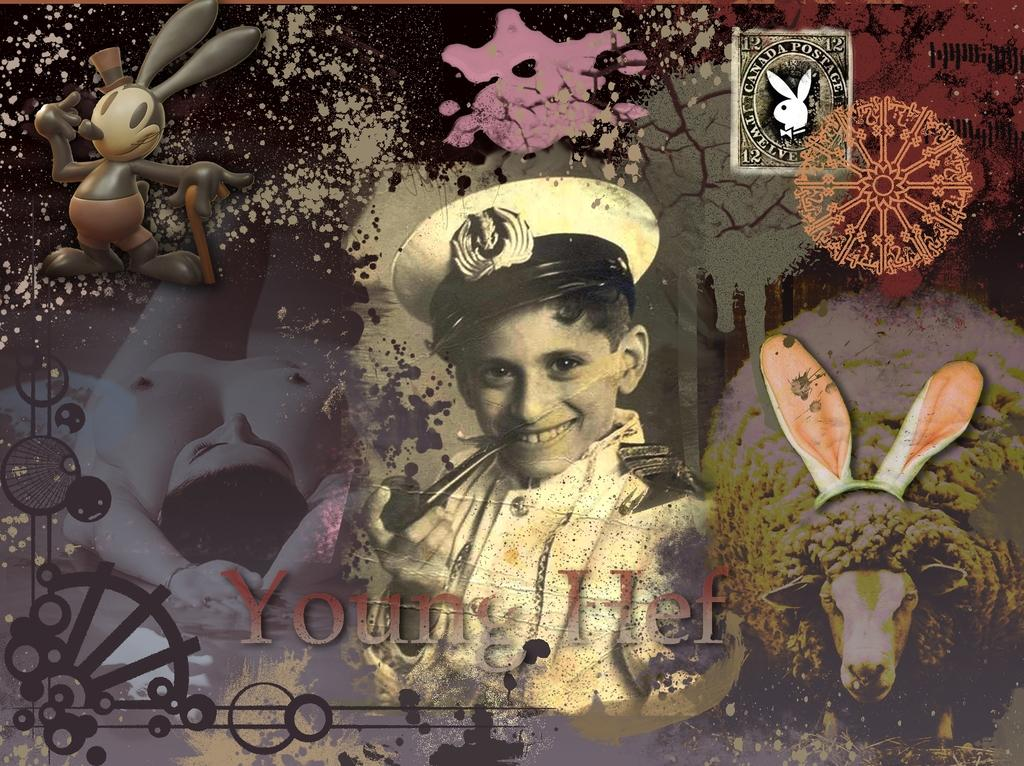What is the main subject in the middle of the image? There is a boy in the middle of the image. What is the boy holding in his hand? The boy is holding a cigar in his hand. What can be seen on the boy's head? The boy has a white cap on his head. What is the other main subject on the left side of the image? There is a nude girl on the left side of the image. What verse is the boy reciting in the image? There is no indication in the image that the boy is reciting a verse. What type of chalk is the doctor using to draw on the wall in the image? There is no doctor or chalk present in the image. 